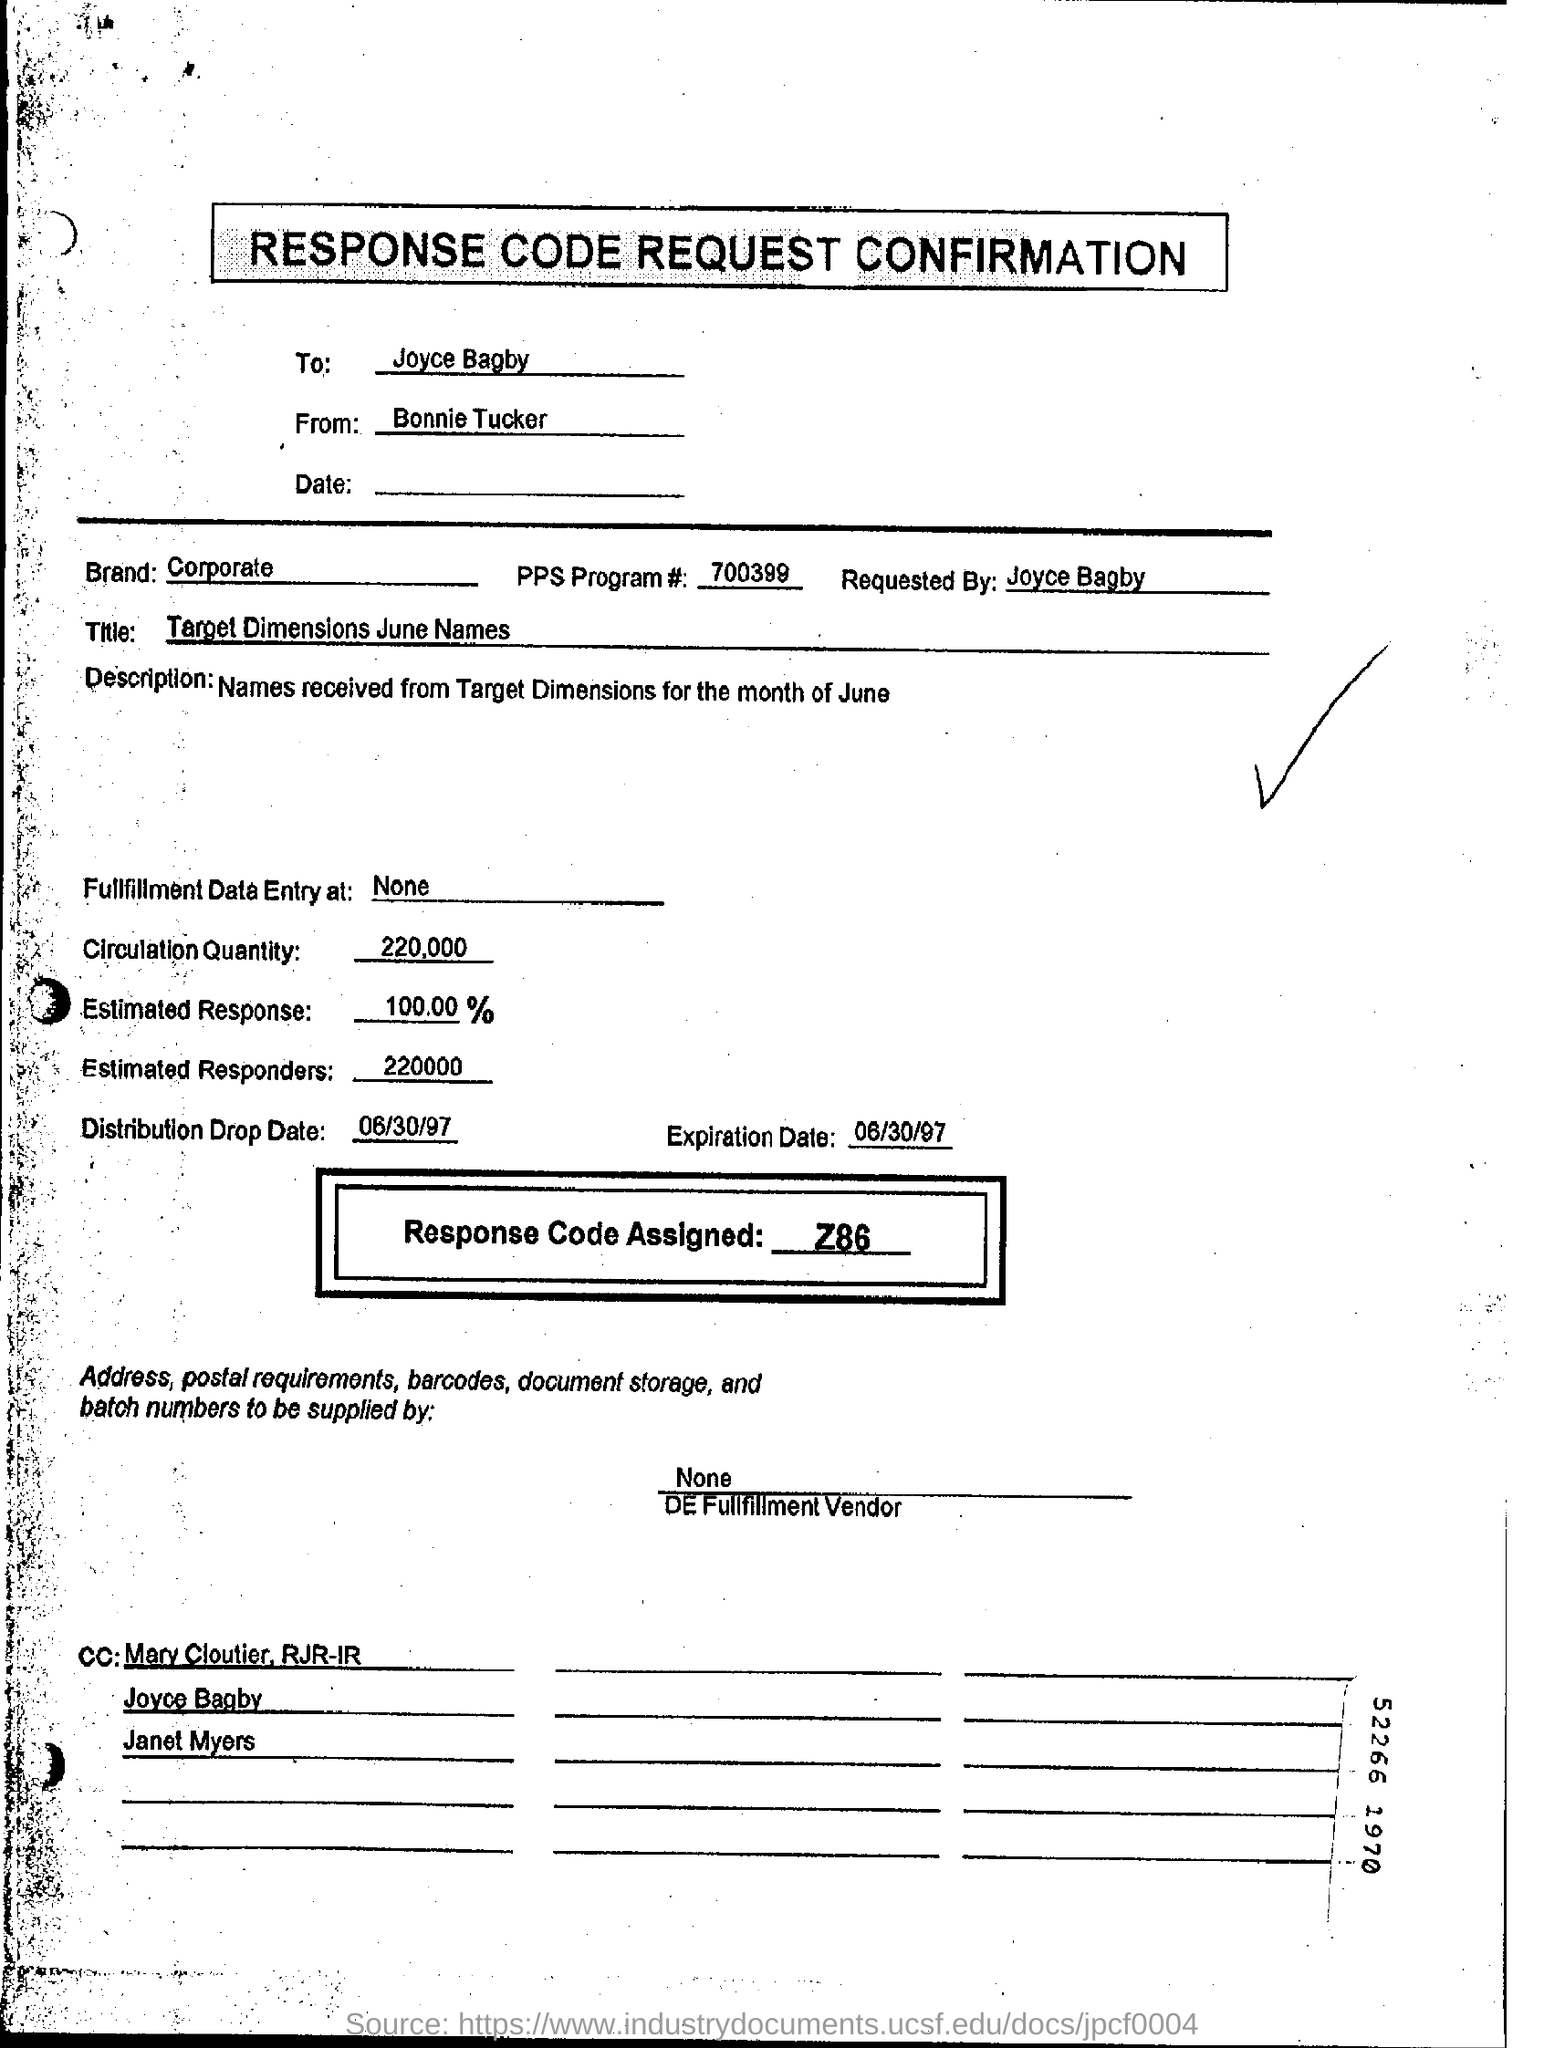Identify some key points in this picture. The circulation quantity is 220,000. The assigned response code is Z86.. The PPS program has the number 700399.... Joyce Bagby is requesting a confirmation of the response code for her request. 